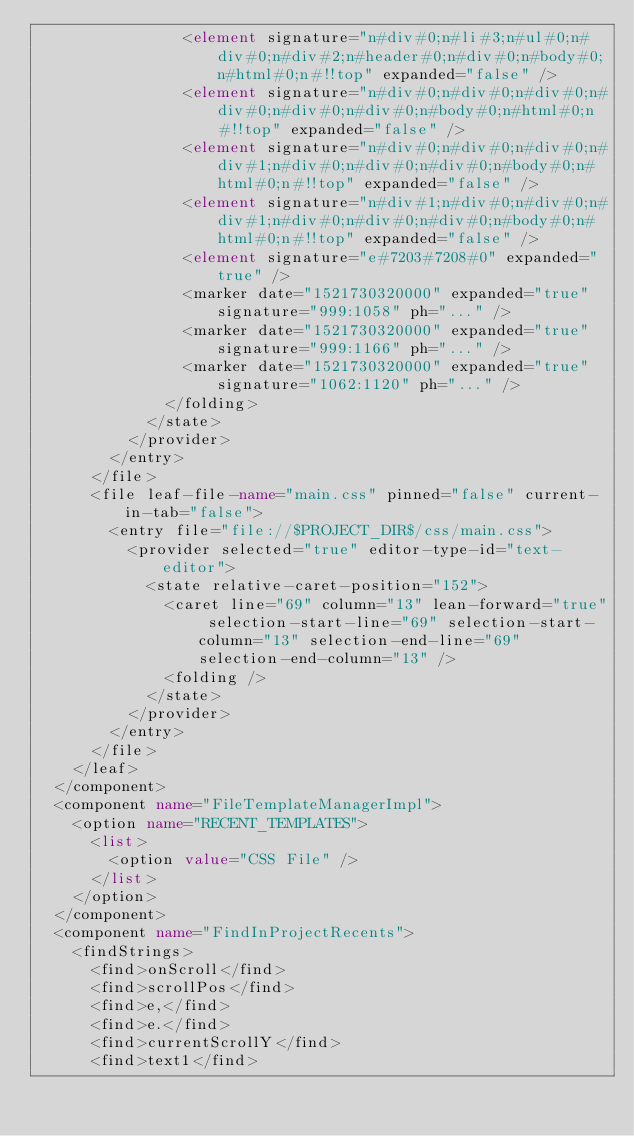Convert code to text. <code><loc_0><loc_0><loc_500><loc_500><_XML_>                <element signature="n#div#0;n#li#3;n#ul#0;n#div#0;n#div#2;n#header#0;n#div#0;n#body#0;n#html#0;n#!!top" expanded="false" />
                <element signature="n#div#0;n#div#0;n#div#0;n#div#0;n#div#0;n#div#0;n#body#0;n#html#0;n#!!top" expanded="false" />
                <element signature="n#div#0;n#div#0;n#div#0;n#div#1;n#div#0;n#div#0;n#div#0;n#body#0;n#html#0;n#!!top" expanded="false" />
                <element signature="n#div#1;n#div#0;n#div#0;n#div#1;n#div#0;n#div#0;n#div#0;n#body#0;n#html#0;n#!!top" expanded="false" />
                <element signature="e#7203#7208#0" expanded="true" />
                <marker date="1521730320000" expanded="true" signature="999:1058" ph="..." />
                <marker date="1521730320000" expanded="true" signature="999:1166" ph="..." />
                <marker date="1521730320000" expanded="true" signature="1062:1120" ph="..." />
              </folding>
            </state>
          </provider>
        </entry>
      </file>
      <file leaf-file-name="main.css" pinned="false" current-in-tab="false">
        <entry file="file://$PROJECT_DIR$/css/main.css">
          <provider selected="true" editor-type-id="text-editor">
            <state relative-caret-position="152">
              <caret line="69" column="13" lean-forward="true" selection-start-line="69" selection-start-column="13" selection-end-line="69" selection-end-column="13" />
              <folding />
            </state>
          </provider>
        </entry>
      </file>
    </leaf>
  </component>
  <component name="FileTemplateManagerImpl">
    <option name="RECENT_TEMPLATES">
      <list>
        <option value="CSS File" />
      </list>
    </option>
  </component>
  <component name="FindInProjectRecents">
    <findStrings>
      <find>onScroll</find>
      <find>scrollPos</find>
      <find>e,</find>
      <find>e.</find>
      <find>currentScrollY</find>
      <find>text1</find></code> 